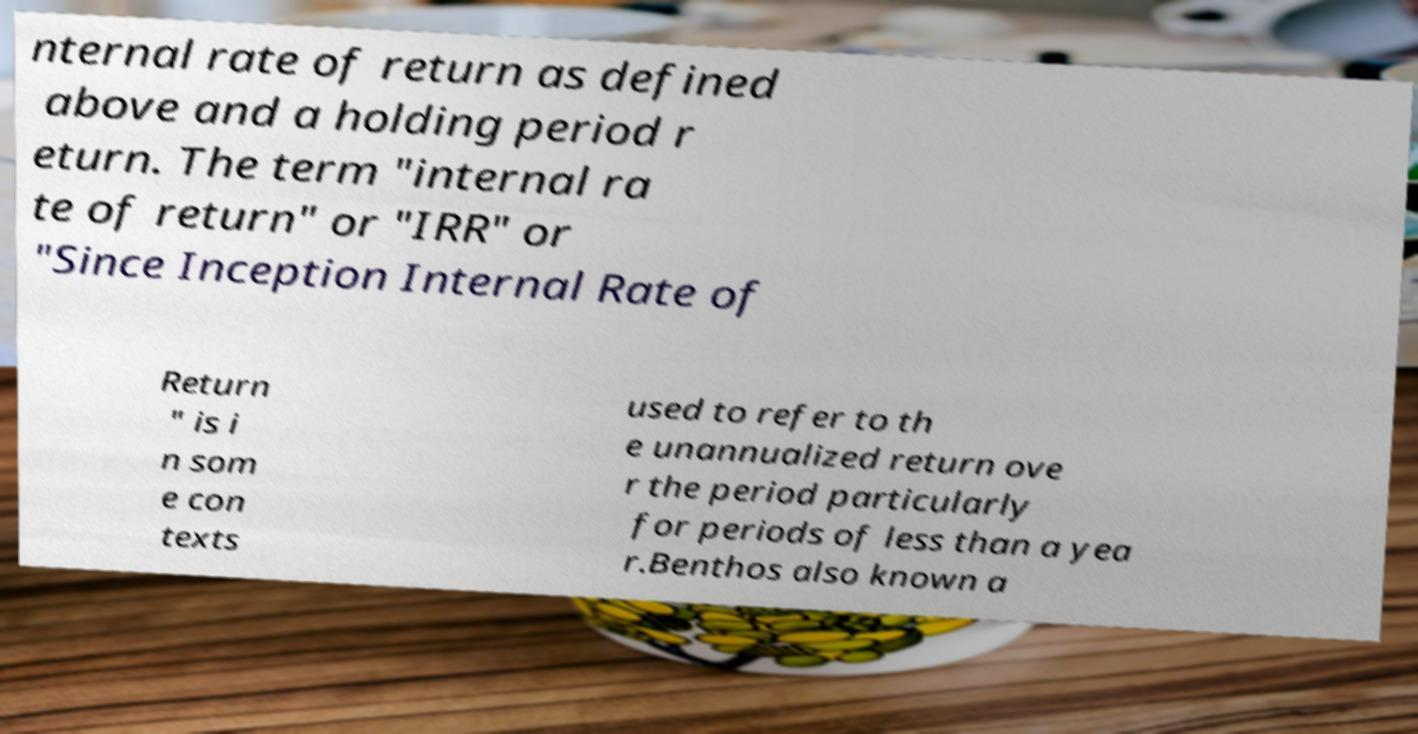What messages or text are displayed in this image? I need them in a readable, typed format. nternal rate of return as defined above and a holding period r eturn. The term "internal ra te of return" or "IRR" or "Since Inception Internal Rate of Return " is i n som e con texts used to refer to th e unannualized return ove r the period particularly for periods of less than a yea r.Benthos also known a 